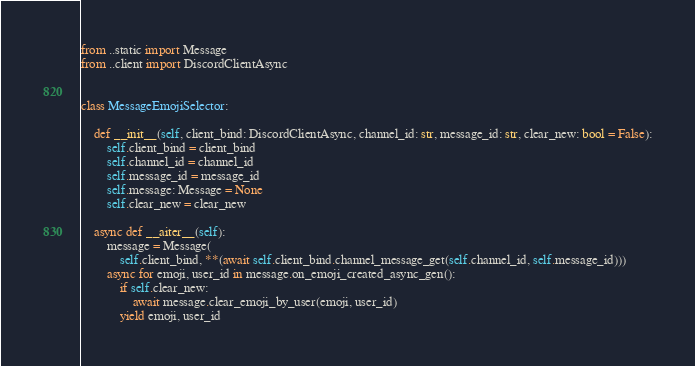Convert code to text. <code><loc_0><loc_0><loc_500><loc_500><_Python_>from ..static import Message
from ..client import DiscordClientAsync


class MessageEmojiSelector:

    def __init__(self, client_bind: DiscordClientAsync, channel_id: str, message_id: str, clear_new: bool = False):
        self.client_bind = client_bind
        self.channel_id = channel_id
        self.message_id = message_id
        self.message: Message = None
        self.clear_new = clear_new

    async def __aiter__(self):
        message = Message(
            self.client_bind, **(await self.client_bind.channel_message_get(self.channel_id, self.message_id)))
        async for emoji, user_id in message.on_emoji_created_async_gen():
            if self.clear_new:
                await message.clear_emoji_by_user(emoji, user_id)
            yield emoji, user_id
</code> 